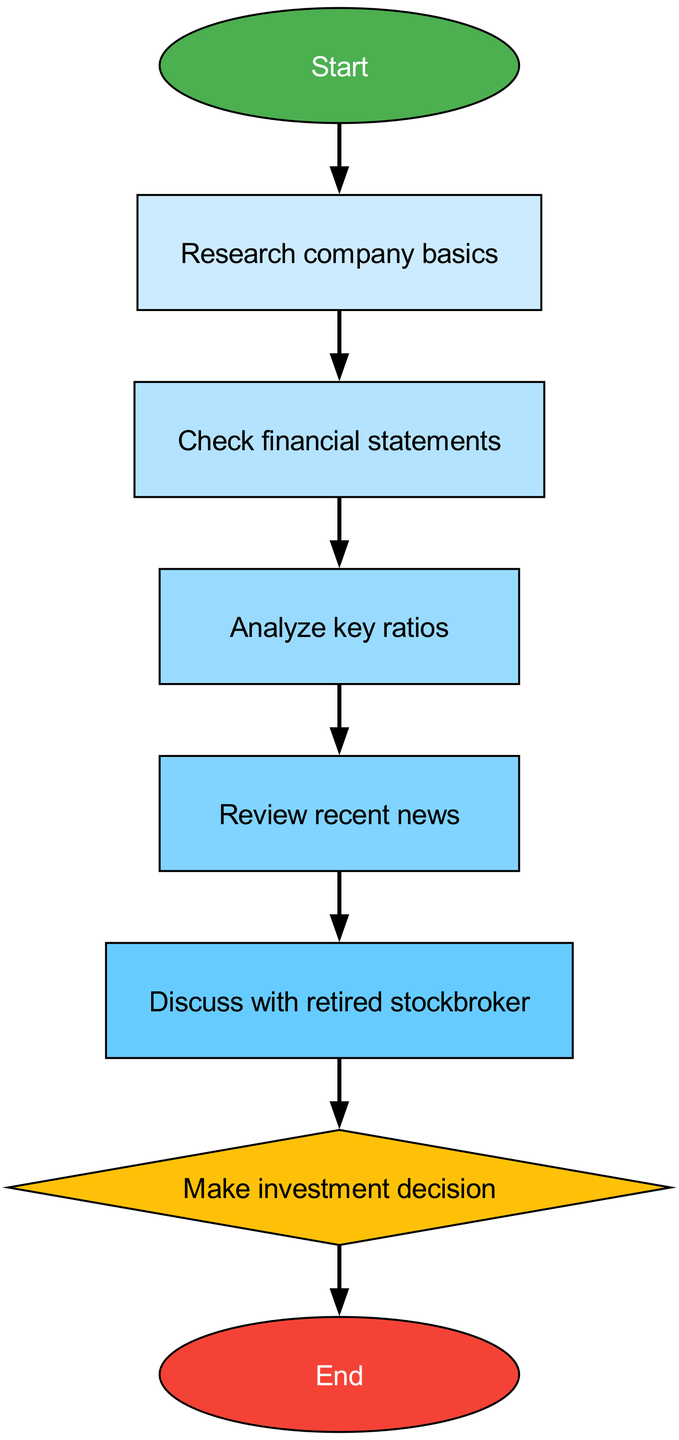What is the first step in the flowchart? The first step, indicated by the node labeled "Start," transitions to the next node which is "Research company basics." Therefore, the answer is derived directly from the first node's text.
Answer: Research company basics How many total nodes are represented in the diagram? Counting all the nodes listed in the diagram, there are eight distinct nodes: Start, Research company basics, Check financial statements, Analyze key ratios, Review recent news, Discuss with retired stockbroker, Make investment decision, and End.
Answer: Eight What node comes after "Analyze key ratios"? Following the flow from the "Analyze key ratios" node, it points to the "Review recent news" node, making that the next step in the process.
Answer: Review recent news What is the purpose of the "decision" node in the diagram? The "decision" node acts as a point where a critical investment decision is made, based on the analysis completed in the preceding nodes. This node is distinctly shaped as a diamond, indicating a key decision point.
Answer: Make investment decision Which node is linked to the "Review recent news"? The "Review recent news" node is connected directly to the "Discuss with retired stockbroker" node, indicating that after reviewing news, one should discuss insights with the stockbroker.
Answer: Discuss with retired stockbroker What shape is used for the "start" and "end" nodes? In the diagram, the "start" node is represented in an elliptical shape, and the "end" node is also in an elliptical shape, both distinguished by their colors.
Answer: Ellipse What color is used for the "decision" node? The "decision" node is colored in yellow, designated to highlight its importance within the flowchart as a point where a key choice is made.
Answer: Yellow How many edges connect the nodes in the flowchart? By examining the listed connections between nodes, there are a total of six edges connecting the various steps clearly in the flowchart.
Answer: Six What role does the "Discuss with retired stockbroker" node play? This node serves as a consultative step where one discusses their findings and thoughts on the analysis before making a financial decision, emphasizing the importance of expert advice in the decision-making process.
Answer: Expert advice 